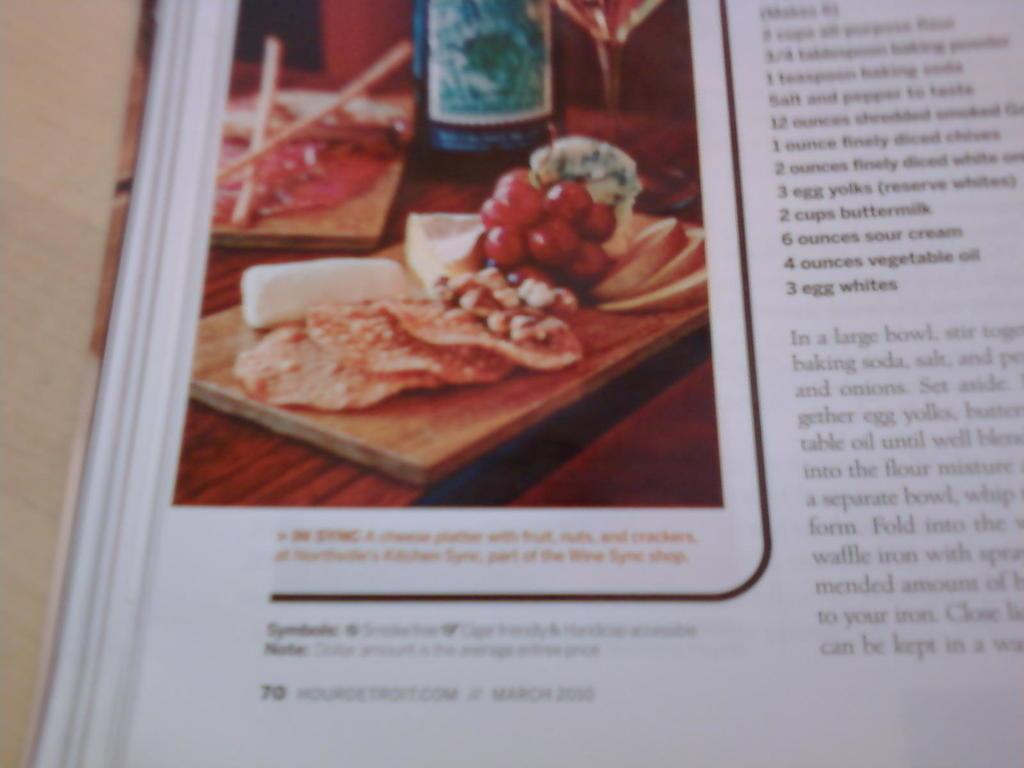What is depicted on the paper in the image? There is a photo on the paper, along with paragraphs and numbers. What type of object is the paper part of? The paper is part of a book. How is the book positioned in the image? The book is placed on a wooden board. What type of bottle is shown in the photo on the paper? There is no bottle present in the image. The photo on the paper does not depict a bottle. 